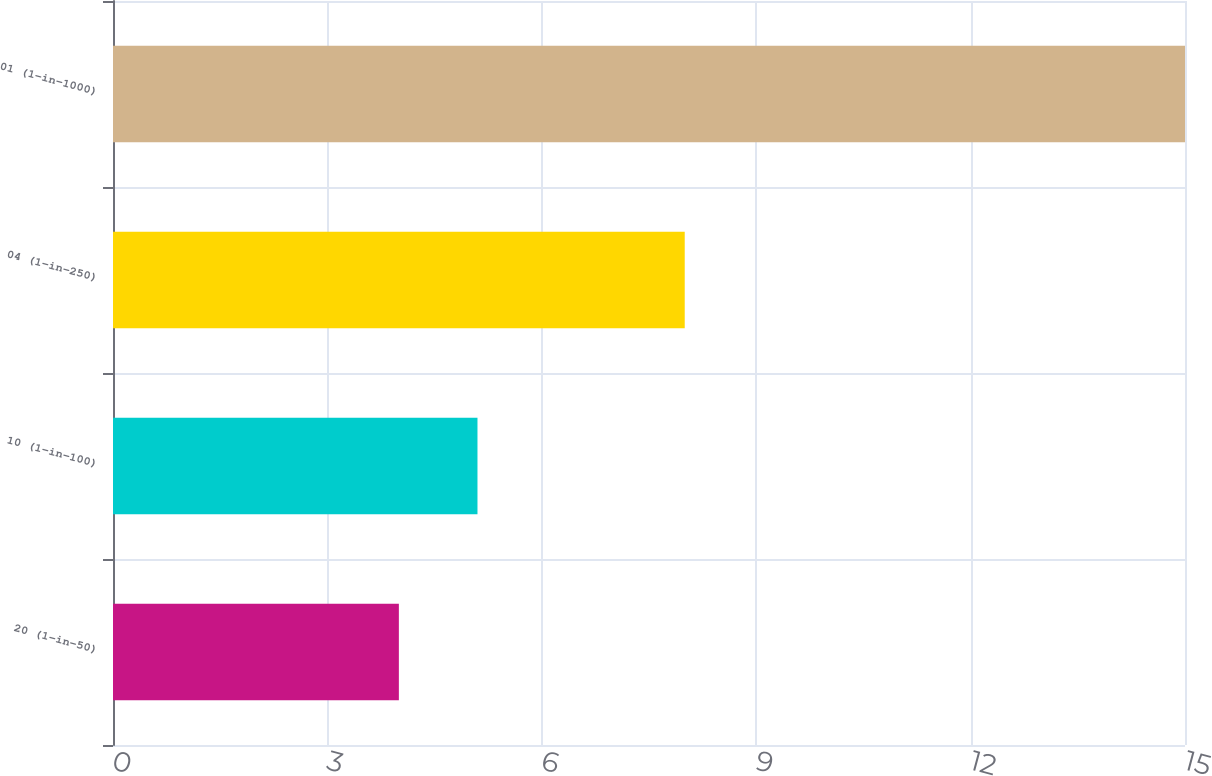Convert chart to OTSL. <chart><loc_0><loc_0><loc_500><loc_500><bar_chart><fcel>20 (1-in-50)<fcel>10 (1-in-100)<fcel>04 (1-in-250)<fcel>01 (1-in-1000)<nl><fcel>4<fcel>5.1<fcel>8<fcel>15<nl></chart> 